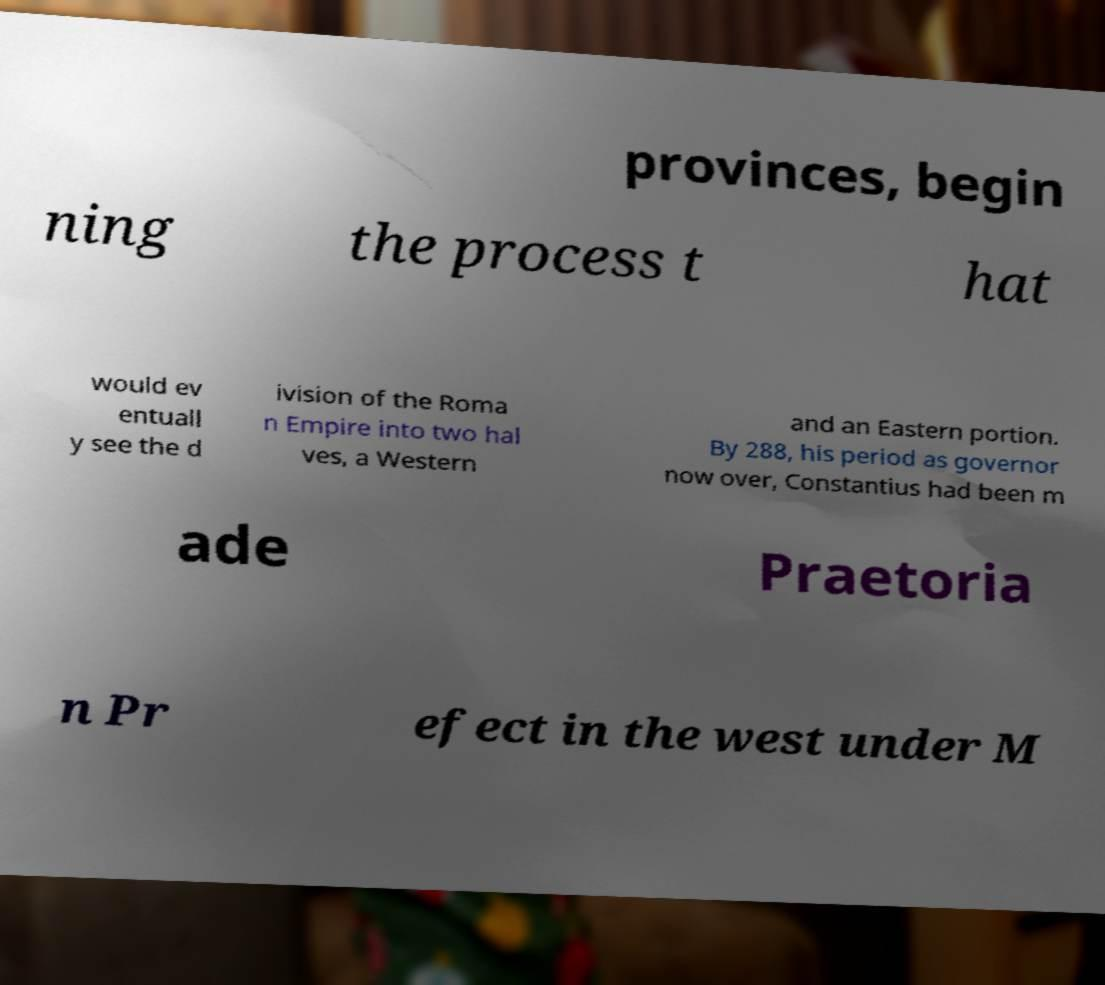Could you assist in decoding the text presented in this image and type it out clearly? provinces, begin ning the process t hat would ev entuall y see the d ivision of the Roma n Empire into two hal ves, a Western and an Eastern portion. By 288, his period as governor now over, Constantius had been m ade Praetoria n Pr efect in the west under M 